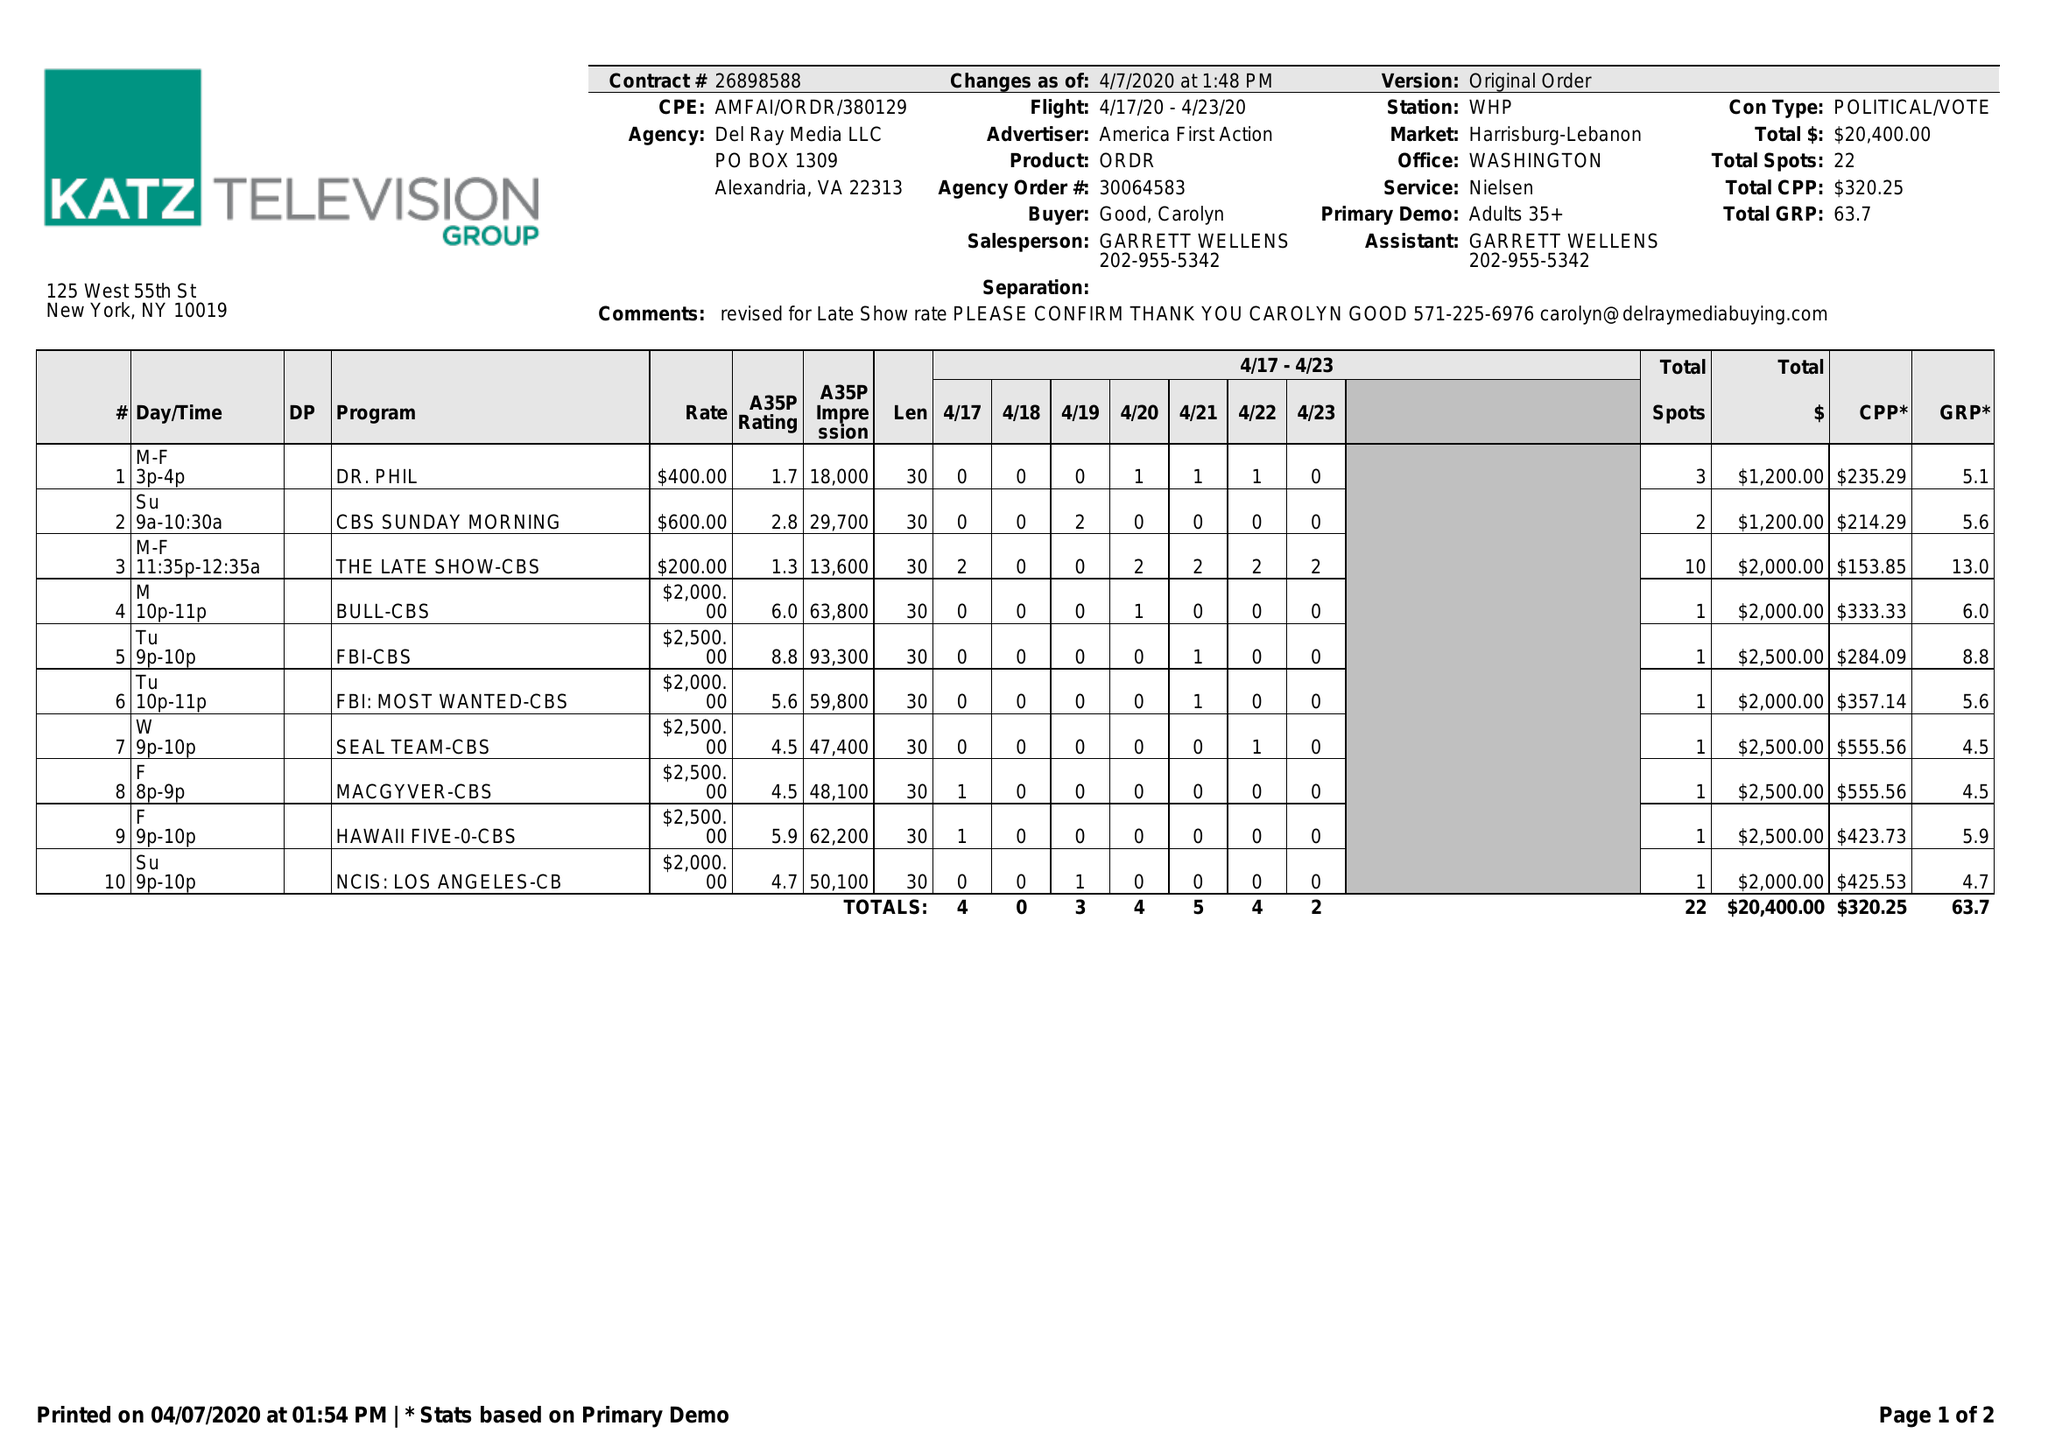What is the value for the flight_from?
Answer the question using a single word or phrase. 04/17/20 